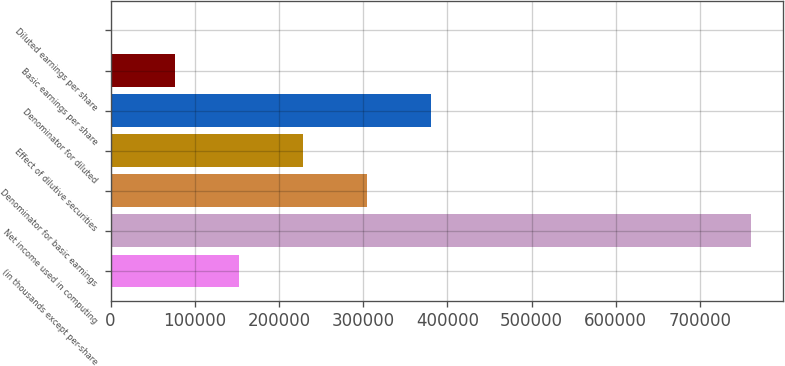Convert chart to OTSL. <chart><loc_0><loc_0><loc_500><loc_500><bar_chart><fcel>(in thousands except per-share<fcel>Net income used in computing<fcel>Denominator for basic earnings<fcel>Effect of dilutive securities<fcel>Denominator for diluted<fcel>Basic earnings per share<fcel>Diluted earnings per share<nl><fcel>152188<fcel>760928<fcel>304373<fcel>228280<fcel>380465<fcel>76095.1<fcel>2.5<nl></chart> 